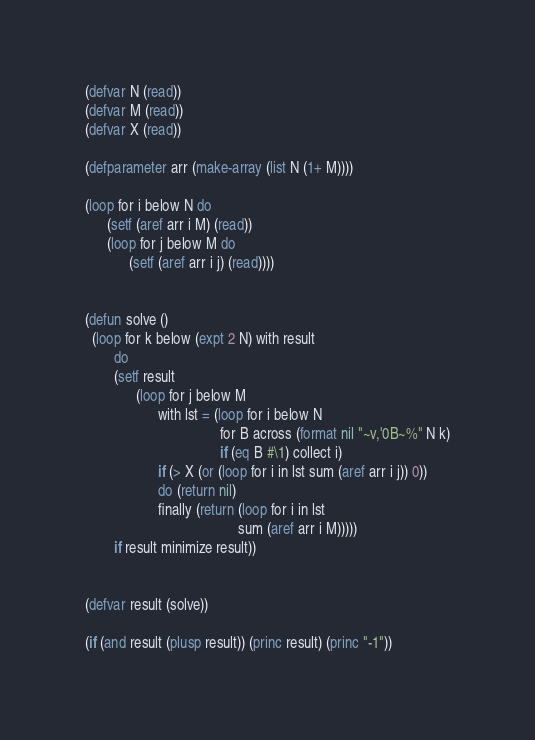Convert code to text. <code><loc_0><loc_0><loc_500><loc_500><_Lisp_>(defvar N (read))
(defvar M (read))
(defvar X (read))

(defparameter arr (make-array (list N (1+ M))))

(loop for i below N do
      (setf (aref arr i M) (read))
      (loop for j below M do
            (setf (aref arr i j) (read))))


(defun solve ()
  (loop for k below (expt 2 N) with result
        do
        (setf result      
              (loop for j below M
                    with lst = (loop for i below N
                                     for B across (format nil "~v,'0B~%" N k)
                                     if (eq B #\1) collect i)
                    if (> X (or (loop for i in lst sum (aref arr i j)) 0))
                    do (return nil)
                    finally (return (loop for i in lst 
                                          sum (aref arr i M)))))
        if result minimize result))


(defvar result (solve))

(if (and result (plusp result)) (princ result) (princ "-1"))</code> 